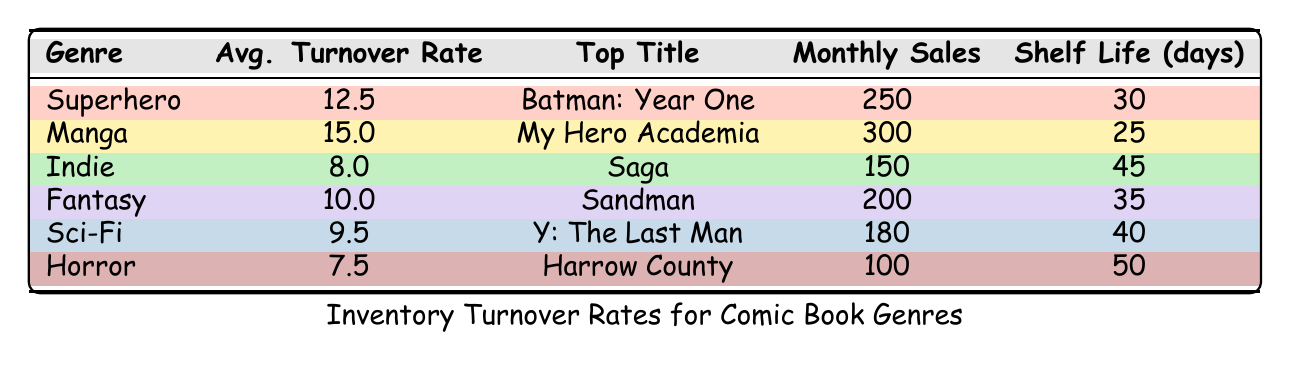What is the average turnover rate for the Manga genre? The table lists the average turnover rate for the Manga genre as 15.0.
Answer: 15.0 Which genre has the highest monthly sales? By looking at the monthly sales column, Manga has the highest monthly sales number of 300.
Answer: Manga Is the average turnover rate for Horror greater than that for Fantasy? The average turnover rates are 7.5 for Horror and 10.0 for Fantasy, so Horror’s rate is not greater than Fantasy’s.
Answer: No What is the total monthly sales for Superhero and Indie genres combined? Adding Superhero's monthly sales (250) and Indie’s (150) gives a total of 250 + 150 = 400.
Answer: 400 Which genre has the longest shelf life? Checking the shelf life column, Horror has the longest shelf life at 50 days.
Answer: Horror What is the average turnover rate for the four genres: Superhero, Manga, Fantasy, and Sci-Fi? Summing the turnover rates for these genres (12.5 + 15.0 + 10.0 + 9.5) gives 47.0; dividing by 4 results in an average of 11.75.
Answer: 11.75 Do Horror and Indie genres have the same average turnover rate? The average turnover rate is 7.5 for Horror and 8.0 for Indie, so they do not have the same rate.
Answer: No If you were to rank genres by average turnover rate, which genre would be in the second position? The turnover rates in descending order: Manga (15.0), Superhero (12.5), Fantasy (10.0), Sci-Fi (9.5), Indie (8.0), Horror (7.5). Thus, Superhero is in the second position.
Answer: Superhero What percentage of the total monthly sales does the Sci-Fi genre contribute? Total monthly sales = 250 + 300 + 150 + 200 + 180 + 100 = 1180. Sci-Fi contributes 180, which is (180/1180) * 100 = 15.25%.
Answer: 15.25% Is there any genre that has an average turnover rate below 8? The only genre with an average turnover rate below 8 is Horror at 7.5.
Answer: Yes 